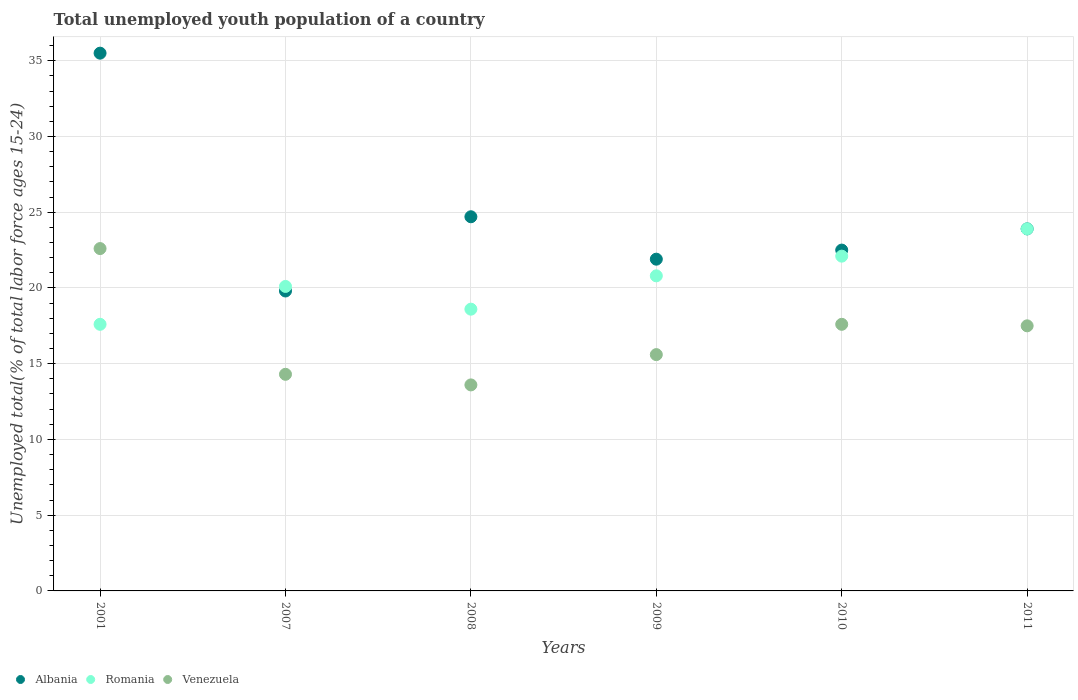What is the percentage of total unemployed youth population of a country in Romania in 2001?
Give a very brief answer. 17.6. Across all years, what is the maximum percentage of total unemployed youth population of a country in Albania?
Provide a short and direct response. 35.5. Across all years, what is the minimum percentage of total unemployed youth population of a country in Romania?
Make the answer very short. 17.6. In which year was the percentage of total unemployed youth population of a country in Romania minimum?
Your answer should be very brief. 2001. What is the total percentage of total unemployed youth population of a country in Albania in the graph?
Your response must be concise. 148.3. What is the difference between the percentage of total unemployed youth population of a country in Venezuela in 2009 and that in 2011?
Your answer should be compact. -1.9. What is the difference between the percentage of total unemployed youth population of a country in Albania in 2009 and the percentage of total unemployed youth population of a country in Romania in 2010?
Offer a terse response. -0.2. What is the average percentage of total unemployed youth population of a country in Venezuela per year?
Ensure brevity in your answer.  16.87. In the year 2008, what is the difference between the percentage of total unemployed youth population of a country in Venezuela and percentage of total unemployed youth population of a country in Albania?
Keep it short and to the point. -11.1. In how many years, is the percentage of total unemployed youth population of a country in Romania greater than 7 %?
Your response must be concise. 6. What is the ratio of the percentage of total unemployed youth population of a country in Venezuela in 2007 to that in 2011?
Offer a very short reply. 0.82. What is the difference between the highest and the second highest percentage of total unemployed youth population of a country in Albania?
Your response must be concise. 10.8. What is the difference between the highest and the lowest percentage of total unemployed youth population of a country in Albania?
Give a very brief answer. 15.7. Is it the case that in every year, the sum of the percentage of total unemployed youth population of a country in Romania and percentage of total unemployed youth population of a country in Venezuela  is greater than the percentage of total unemployed youth population of a country in Albania?
Give a very brief answer. Yes. Does the percentage of total unemployed youth population of a country in Romania monotonically increase over the years?
Give a very brief answer. No. Is the percentage of total unemployed youth population of a country in Venezuela strictly greater than the percentage of total unemployed youth population of a country in Albania over the years?
Ensure brevity in your answer.  No. Is the percentage of total unemployed youth population of a country in Venezuela strictly less than the percentage of total unemployed youth population of a country in Romania over the years?
Your answer should be compact. No. How many years are there in the graph?
Keep it short and to the point. 6. What is the difference between two consecutive major ticks on the Y-axis?
Offer a very short reply. 5. Where does the legend appear in the graph?
Ensure brevity in your answer.  Bottom left. How many legend labels are there?
Your answer should be compact. 3. What is the title of the graph?
Provide a succinct answer. Total unemployed youth population of a country. Does "Isle of Man" appear as one of the legend labels in the graph?
Provide a short and direct response. No. What is the label or title of the X-axis?
Offer a very short reply. Years. What is the label or title of the Y-axis?
Offer a terse response. Unemployed total(% of total labor force ages 15-24). What is the Unemployed total(% of total labor force ages 15-24) in Albania in 2001?
Your answer should be compact. 35.5. What is the Unemployed total(% of total labor force ages 15-24) in Romania in 2001?
Provide a succinct answer. 17.6. What is the Unemployed total(% of total labor force ages 15-24) of Venezuela in 2001?
Provide a succinct answer. 22.6. What is the Unemployed total(% of total labor force ages 15-24) of Albania in 2007?
Give a very brief answer. 19.8. What is the Unemployed total(% of total labor force ages 15-24) in Romania in 2007?
Your response must be concise. 20.1. What is the Unemployed total(% of total labor force ages 15-24) of Venezuela in 2007?
Give a very brief answer. 14.3. What is the Unemployed total(% of total labor force ages 15-24) in Albania in 2008?
Offer a terse response. 24.7. What is the Unemployed total(% of total labor force ages 15-24) in Romania in 2008?
Your response must be concise. 18.6. What is the Unemployed total(% of total labor force ages 15-24) in Venezuela in 2008?
Make the answer very short. 13.6. What is the Unemployed total(% of total labor force ages 15-24) of Albania in 2009?
Provide a short and direct response. 21.9. What is the Unemployed total(% of total labor force ages 15-24) of Romania in 2009?
Ensure brevity in your answer.  20.8. What is the Unemployed total(% of total labor force ages 15-24) in Venezuela in 2009?
Ensure brevity in your answer.  15.6. What is the Unemployed total(% of total labor force ages 15-24) in Romania in 2010?
Your answer should be very brief. 22.1. What is the Unemployed total(% of total labor force ages 15-24) in Venezuela in 2010?
Offer a very short reply. 17.6. What is the Unemployed total(% of total labor force ages 15-24) of Albania in 2011?
Provide a succinct answer. 23.9. What is the Unemployed total(% of total labor force ages 15-24) of Romania in 2011?
Ensure brevity in your answer.  23.9. Across all years, what is the maximum Unemployed total(% of total labor force ages 15-24) in Albania?
Provide a succinct answer. 35.5. Across all years, what is the maximum Unemployed total(% of total labor force ages 15-24) of Romania?
Your answer should be very brief. 23.9. Across all years, what is the maximum Unemployed total(% of total labor force ages 15-24) of Venezuela?
Make the answer very short. 22.6. Across all years, what is the minimum Unemployed total(% of total labor force ages 15-24) in Albania?
Make the answer very short. 19.8. Across all years, what is the minimum Unemployed total(% of total labor force ages 15-24) of Romania?
Make the answer very short. 17.6. Across all years, what is the minimum Unemployed total(% of total labor force ages 15-24) in Venezuela?
Provide a succinct answer. 13.6. What is the total Unemployed total(% of total labor force ages 15-24) in Albania in the graph?
Your answer should be very brief. 148.3. What is the total Unemployed total(% of total labor force ages 15-24) of Romania in the graph?
Offer a terse response. 123.1. What is the total Unemployed total(% of total labor force ages 15-24) of Venezuela in the graph?
Offer a terse response. 101.2. What is the difference between the Unemployed total(% of total labor force ages 15-24) of Albania in 2001 and that in 2007?
Keep it short and to the point. 15.7. What is the difference between the Unemployed total(% of total labor force ages 15-24) in Romania in 2001 and that in 2007?
Your answer should be very brief. -2.5. What is the difference between the Unemployed total(% of total labor force ages 15-24) of Venezuela in 2001 and that in 2007?
Your answer should be compact. 8.3. What is the difference between the Unemployed total(% of total labor force ages 15-24) of Romania in 2001 and that in 2008?
Give a very brief answer. -1. What is the difference between the Unemployed total(% of total labor force ages 15-24) of Venezuela in 2001 and that in 2008?
Ensure brevity in your answer.  9. What is the difference between the Unemployed total(% of total labor force ages 15-24) of Romania in 2001 and that in 2009?
Ensure brevity in your answer.  -3.2. What is the difference between the Unemployed total(% of total labor force ages 15-24) in Albania in 2001 and that in 2010?
Make the answer very short. 13. What is the difference between the Unemployed total(% of total labor force ages 15-24) in Romania in 2001 and that in 2010?
Provide a short and direct response. -4.5. What is the difference between the Unemployed total(% of total labor force ages 15-24) in Venezuela in 2001 and that in 2010?
Offer a very short reply. 5. What is the difference between the Unemployed total(% of total labor force ages 15-24) in Venezuela in 2001 and that in 2011?
Keep it short and to the point. 5.1. What is the difference between the Unemployed total(% of total labor force ages 15-24) of Albania in 2007 and that in 2008?
Ensure brevity in your answer.  -4.9. What is the difference between the Unemployed total(% of total labor force ages 15-24) in Romania in 2007 and that in 2008?
Offer a very short reply. 1.5. What is the difference between the Unemployed total(% of total labor force ages 15-24) in Venezuela in 2007 and that in 2009?
Your answer should be compact. -1.3. What is the difference between the Unemployed total(% of total labor force ages 15-24) of Romania in 2007 and that in 2010?
Your answer should be compact. -2. What is the difference between the Unemployed total(% of total labor force ages 15-24) in Albania in 2008 and that in 2009?
Keep it short and to the point. 2.8. What is the difference between the Unemployed total(% of total labor force ages 15-24) of Romania in 2008 and that in 2009?
Keep it short and to the point. -2.2. What is the difference between the Unemployed total(% of total labor force ages 15-24) in Romania in 2008 and that in 2010?
Give a very brief answer. -3.5. What is the difference between the Unemployed total(% of total labor force ages 15-24) in Venezuela in 2008 and that in 2011?
Your answer should be compact. -3.9. What is the difference between the Unemployed total(% of total labor force ages 15-24) of Albania in 2009 and that in 2010?
Your answer should be very brief. -0.6. What is the difference between the Unemployed total(% of total labor force ages 15-24) in Romania in 2009 and that in 2010?
Offer a terse response. -1.3. What is the difference between the Unemployed total(% of total labor force ages 15-24) of Albania in 2009 and that in 2011?
Your response must be concise. -2. What is the difference between the Unemployed total(% of total labor force ages 15-24) in Romania in 2009 and that in 2011?
Give a very brief answer. -3.1. What is the difference between the Unemployed total(% of total labor force ages 15-24) of Albania in 2010 and that in 2011?
Ensure brevity in your answer.  -1.4. What is the difference between the Unemployed total(% of total labor force ages 15-24) of Albania in 2001 and the Unemployed total(% of total labor force ages 15-24) of Venezuela in 2007?
Make the answer very short. 21.2. What is the difference between the Unemployed total(% of total labor force ages 15-24) of Albania in 2001 and the Unemployed total(% of total labor force ages 15-24) of Romania in 2008?
Provide a short and direct response. 16.9. What is the difference between the Unemployed total(% of total labor force ages 15-24) in Albania in 2001 and the Unemployed total(% of total labor force ages 15-24) in Venezuela in 2008?
Ensure brevity in your answer.  21.9. What is the difference between the Unemployed total(% of total labor force ages 15-24) in Romania in 2001 and the Unemployed total(% of total labor force ages 15-24) in Venezuela in 2008?
Ensure brevity in your answer.  4. What is the difference between the Unemployed total(% of total labor force ages 15-24) of Albania in 2001 and the Unemployed total(% of total labor force ages 15-24) of Venezuela in 2010?
Ensure brevity in your answer.  17.9. What is the difference between the Unemployed total(% of total labor force ages 15-24) in Albania in 2001 and the Unemployed total(% of total labor force ages 15-24) in Venezuela in 2011?
Give a very brief answer. 18. What is the difference between the Unemployed total(% of total labor force ages 15-24) of Romania in 2001 and the Unemployed total(% of total labor force ages 15-24) of Venezuela in 2011?
Give a very brief answer. 0.1. What is the difference between the Unemployed total(% of total labor force ages 15-24) of Albania in 2007 and the Unemployed total(% of total labor force ages 15-24) of Romania in 2008?
Give a very brief answer. 1.2. What is the difference between the Unemployed total(% of total labor force ages 15-24) in Albania in 2007 and the Unemployed total(% of total labor force ages 15-24) in Venezuela in 2008?
Your answer should be very brief. 6.2. What is the difference between the Unemployed total(% of total labor force ages 15-24) in Romania in 2007 and the Unemployed total(% of total labor force ages 15-24) in Venezuela in 2008?
Provide a succinct answer. 6.5. What is the difference between the Unemployed total(% of total labor force ages 15-24) of Albania in 2007 and the Unemployed total(% of total labor force ages 15-24) of Romania in 2009?
Ensure brevity in your answer.  -1. What is the difference between the Unemployed total(% of total labor force ages 15-24) of Romania in 2007 and the Unemployed total(% of total labor force ages 15-24) of Venezuela in 2009?
Ensure brevity in your answer.  4.5. What is the difference between the Unemployed total(% of total labor force ages 15-24) in Albania in 2007 and the Unemployed total(% of total labor force ages 15-24) in Venezuela in 2010?
Make the answer very short. 2.2. What is the difference between the Unemployed total(% of total labor force ages 15-24) in Romania in 2007 and the Unemployed total(% of total labor force ages 15-24) in Venezuela in 2010?
Your answer should be very brief. 2.5. What is the difference between the Unemployed total(% of total labor force ages 15-24) of Albania in 2007 and the Unemployed total(% of total labor force ages 15-24) of Romania in 2011?
Provide a short and direct response. -4.1. What is the difference between the Unemployed total(% of total labor force ages 15-24) of Albania in 2007 and the Unemployed total(% of total labor force ages 15-24) of Venezuela in 2011?
Keep it short and to the point. 2.3. What is the difference between the Unemployed total(% of total labor force ages 15-24) of Romania in 2007 and the Unemployed total(% of total labor force ages 15-24) of Venezuela in 2011?
Your response must be concise. 2.6. What is the difference between the Unemployed total(% of total labor force ages 15-24) in Albania in 2008 and the Unemployed total(% of total labor force ages 15-24) in Romania in 2009?
Provide a short and direct response. 3.9. What is the difference between the Unemployed total(% of total labor force ages 15-24) in Albania in 2008 and the Unemployed total(% of total labor force ages 15-24) in Venezuela in 2009?
Make the answer very short. 9.1. What is the difference between the Unemployed total(% of total labor force ages 15-24) in Albania in 2008 and the Unemployed total(% of total labor force ages 15-24) in Romania in 2010?
Make the answer very short. 2.6. What is the difference between the Unemployed total(% of total labor force ages 15-24) in Albania in 2008 and the Unemployed total(% of total labor force ages 15-24) in Venezuela in 2010?
Keep it short and to the point. 7.1. What is the difference between the Unemployed total(% of total labor force ages 15-24) in Albania in 2008 and the Unemployed total(% of total labor force ages 15-24) in Romania in 2011?
Offer a terse response. 0.8. What is the difference between the Unemployed total(% of total labor force ages 15-24) in Albania in 2008 and the Unemployed total(% of total labor force ages 15-24) in Venezuela in 2011?
Your answer should be compact. 7.2. What is the difference between the Unemployed total(% of total labor force ages 15-24) of Albania in 2009 and the Unemployed total(% of total labor force ages 15-24) of Romania in 2011?
Your response must be concise. -2. What is the difference between the Unemployed total(% of total labor force ages 15-24) in Romania in 2009 and the Unemployed total(% of total labor force ages 15-24) in Venezuela in 2011?
Provide a short and direct response. 3.3. What is the average Unemployed total(% of total labor force ages 15-24) of Albania per year?
Offer a terse response. 24.72. What is the average Unemployed total(% of total labor force ages 15-24) in Romania per year?
Give a very brief answer. 20.52. What is the average Unemployed total(% of total labor force ages 15-24) in Venezuela per year?
Give a very brief answer. 16.87. In the year 2001, what is the difference between the Unemployed total(% of total labor force ages 15-24) of Albania and Unemployed total(% of total labor force ages 15-24) of Romania?
Offer a very short reply. 17.9. In the year 2001, what is the difference between the Unemployed total(% of total labor force ages 15-24) in Romania and Unemployed total(% of total labor force ages 15-24) in Venezuela?
Provide a succinct answer. -5. In the year 2007, what is the difference between the Unemployed total(% of total labor force ages 15-24) in Albania and Unemployed total(% of total labor force ages 15-24) in Venezuela?
Your response must be concise. 5.5. In the year 2007, what is the difference between the Unemployed total(% of total labor force ages 15-24) in Romania and Unemployed total(% of total labor force ages 15-24) in Venezuela?
Keep it short and to the point. 5.8. In the year 2008, what is the difference between the Unemployed total(% of total labor force ages 15-24) in Albania and Unemployed total(% of total labor force ages 15-24) in Romania?
Your response must be concise. 6.1. In the year 2008, what is the difference between the Unemployed total(% of total labor force ages 15-24) of Albania and Unemployed total(% of total labor force ages 15-24) of Venezuela?
Offer a terse response. 11.1. In the year 2008, what is the difference between the Unemployed total(% of total labor force ages 15-24) in Romania and Unemployed total(% of total labor force ages 15-24) in Venezuela?
Ensure brevity in your answer.  5. In the year 2009, what is the difference between the Unemployed total(% of total labor force ages 15-24) in Albania and Unemployed total(% of total labor force ages 15-24) in Romania?
Give a very brief answer. 1.1. In the year 2009, what is the difference between the Unemployed total(% of total labor force ages 15-24) in Romania and Unemployed total(% of total labor force ages 15-24) in Venezuela?
Your response must be concise. 5.2. In the year 2010, what is the difference between the Unemployed total(% of total labor force ages 15-24) of Albania and Unemployed total(% of total labor force ages 15-24) of Venezuela?
Your answer should be compact. 4.9. What is the ratio of the Unemployed total(% of total labor force ages 15-24) in Albania in 2001 to that in 2007?
Your response must be concise. 1.79. What is the ratio of the Unemployed total(% of total labor force ages 15-24) of Romania in 2001 to that in 2007?
Make the answer very short. 0.88. What is the ratio of the Unemployed total(% of total labor force ages 15-24) in Venezuela in 2001 to that in 2007?
Ensure brevity in your answer.  1.58. What is the ratio of the Unemployed total(% of total labor force ages 15-24) in Albania in 2001 to that in 2008?
Your answer should be compact. 1.44. What is the ratio of the Unemployed total(% of total labor force ages 15-24) of Romania in 2001 to that in 2008?
Provide a short and direct response. 0.95. What is the ratio of the Unemployed total(% of total labor force ages 15-24) of Venezuela in 2001 to that in 2008?
Keep it short and to the point. 1.66. What is the ratio of the Unemployed total(% of total labor force ages 15-24) of Albania in 2001 to that in 2009?
Your answer should be very brief. 1.62. What is the ratio of the Unemployed total(% of total labor force ages 15-24) of Romania in 2001 to that in 2009?
Offer a terse response. 0.85. What is the ratio of the Unemployed total(% of total labor force ages 15-24) in Venezuela in 2001 to that in 2009?
Make the answer very short. 1.45. What is the ratio of the Unemployed total(% of total labor force ages 15-24) of Albania in 2001 to that in 2010?
Offer a very short reply. 1.58. What is the ratio of the Unemployed total(% of total labor force ages 15-24) in Romania in 2001 to that in 2010?
Make the answer very short. 0.8. What is the ratio of the Unemployed total(% of total labor force ages 15-24) in Venezuela in 2001 to that in 2010?
Your answer should be compact. 1.28. What is the ratio of the Unemployed total(% of total labor force ages 15-24) of Albania in 2001 to that in 2011?
Your answer should be compact. 1.49. What is the ratio of the Unemployed total(% of total labor force ages 15-24) of Romania in 2001 to that in 2011?
Offer a terse response. 0.74. What is the ratio of the Unemployed total(% of total labor force ages 15-24) of Venezuela in 2001 to that in 2011?
Your answer should be very brief. 1.29. What is the ratio of the Unemployed total(% of total labor force ages 15-24) of Albania in 2007 to that in 2008?
Provide a succinct answer. 0.8. What is the ratio of the Unemployed total(% of total labor force ages 15-24) in Romania in 2007 to that in 2008?
Ensure brevity in your answer.  1.08. What is the ratio of the Unemployed total(% of total labor force ages 15-24) in Venezuela in 2007 to that in 2008?
Offer a terse response. 1.05. What is the ratio of the Unemployed total(% of total labor force ages 15-24) of Albania in 2007 to that in 2009?
Give a very brief answer. 0.9. What is the ratio of the Unemployed total(% of total labor force ages 15-24) of Romania in 2007 to that in 2009?
Your response must be concise. 0.97. What is the ratio of the Unemployed total(% of total labor force ages 15-24) in Venezuela in 2007 to that in 2009?
Give a very brief answer. 0.92. What is the ratio of the Unemployed total(% of total labor force ages 15-24) of Romania in 2007 to that in 2010?
Make the answer very short. 0.91. What is the ratio of the Unemployed total(% of total labor force ages 15-24) in Venezuela in 2007 to that in 2010?
Keep it short and to the point. 0.81. What is the ratio of the Unemployed total(% of total labor force ages 15-24) in Albania in 2007 to that in 2011?
Ensure brevity in your answer.  0.83. What is the ratio of the Unemployed total(% of total labor force ages 15-24) in Romania in 2007 to that in 2011?
Your answer should be very brief. 0.84. What is the ratio of the Unemployed total(% of total labor force ages 15-24) of Venezuela in 2007 to that in 2011?
Your answer should be compact. 0.82. What is the ratio of the Unemployed total(% of total labor force ages 15-24) of Albania in 2008 to that in 2009?
Provide a short and direct response. 1.13. What is the ratio of the Unemployed total(% of total labor force ages 15-24) in Romania in 2008 to that in 2009?
Ensure brevity in your answer.  0.89. What is the ratio of the Unemployed total(% of total labor force ages 15-24) of Venezuela in 2008 to that in 2009?
Your response must be concise. 0.87. What is the ratio of the Unemployed total(% of total labor force ages 15-24) in Albania in 2008 to that in 2010?
Provide a succinct answer. 1.1. What is the ratio of the Unemployed total(% of total labor force ages 15-24) of Romania in 2008 to that in 2010?
Provide a succinct answer. 0.84. What is the ratio of the Unemployed total(% of total labor force ages 15-24) in Venezuela in 2008 to that in 2010?
Ensure brevity in your answer.  0.77. What is the ratio of the Unemployed total(% of total labor force ages 15-24) in Albania in 2008 to that in 2011?
Offer a terse response. 1.03. What is the ratio of the Unemployed total(% of total labor force ages 15-24) in Romania in 2008 to that in 2011?
Offer a very short reply. 0.78. What is the ratio of the Unemployed total(% of total labor force ages 15-24) in Venezuela in 2008 to that in 2011?
Offer a very short reply. 0.78. What is the ratio of the Unemployed total(% of total labor force ages 15-24) in Albania in 2009 to that in 2010?
Your answer should be compact. 0.97. What is the ratio of the Unemployed total(% of total labor force ages 15-24) in Romania in 2009 to that in 2010?
Offer a terse response. 0.94. What is the ratio of the Unemployed total(% of total labor force ages 15-24) in Venezuela in 2009 to that in 2010?
Offer a very short reply. 0.89. What is the ratio of the Unemployed total(% of total labor force ages 15-24) in Albania in 2009 to that in 2011?
Ensure brevity in your answer.  0.92. What is the ratio of the Unemployed total(% of total labor force ages 15-24) in Romania in 2009 to that in 2011?
Offer a terse response. 0.87. What is the ratio of the Unemployed total(% of total labor force ages 15-24) in Venezuela in 2009 to that in 2011?
Your response must be concise. 0.89. What is the ratio of the Unemployed total(% of total labor force ages 15-24) in Albania in 2010 to that in 2011?
Ensure brevity in your answer.  0.94. What is the ratio of the Unemployed total(% of total labor force ages 15-24) of Romania in 2010 to that in 2011?
Offer a terse response. 0.92. What is the difference between the highest and the second highest Unemployed total(% of total labor force ages 15-24) of Albania?
Offer a terse response. 10.8. What is the difference between the highest and the second highest Unemployed total(% of total labor force ages 15-24) of Romania?
Ensure brevity in your answer.  1.8. 